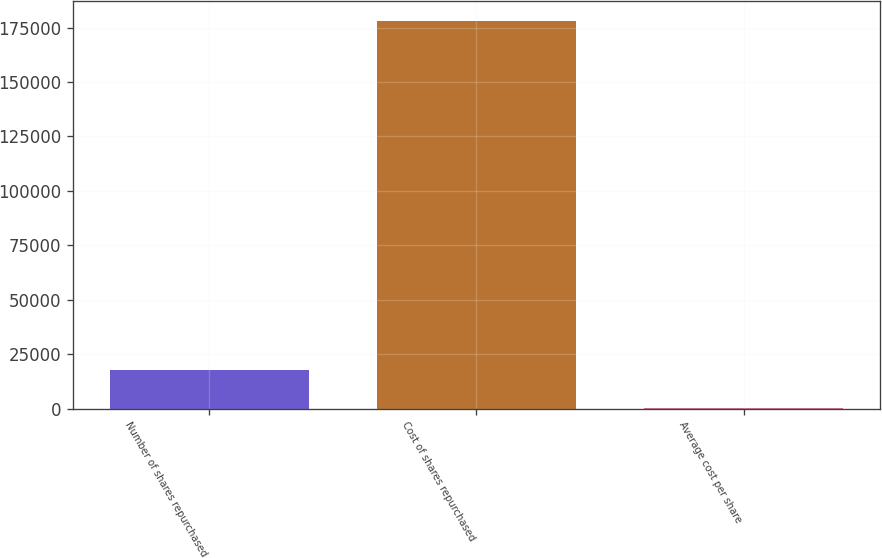Convert chart to OTSL. <chart><loc_0><loc_0><loc_500><loc_500><bar_chart><fcel>Number of shares repurchased<fcel>Cost of shares repurchased<fcel>Average cost per share<nl><fcel>17880.2<fcel>178165<fcel>70.77<nl></chart> 